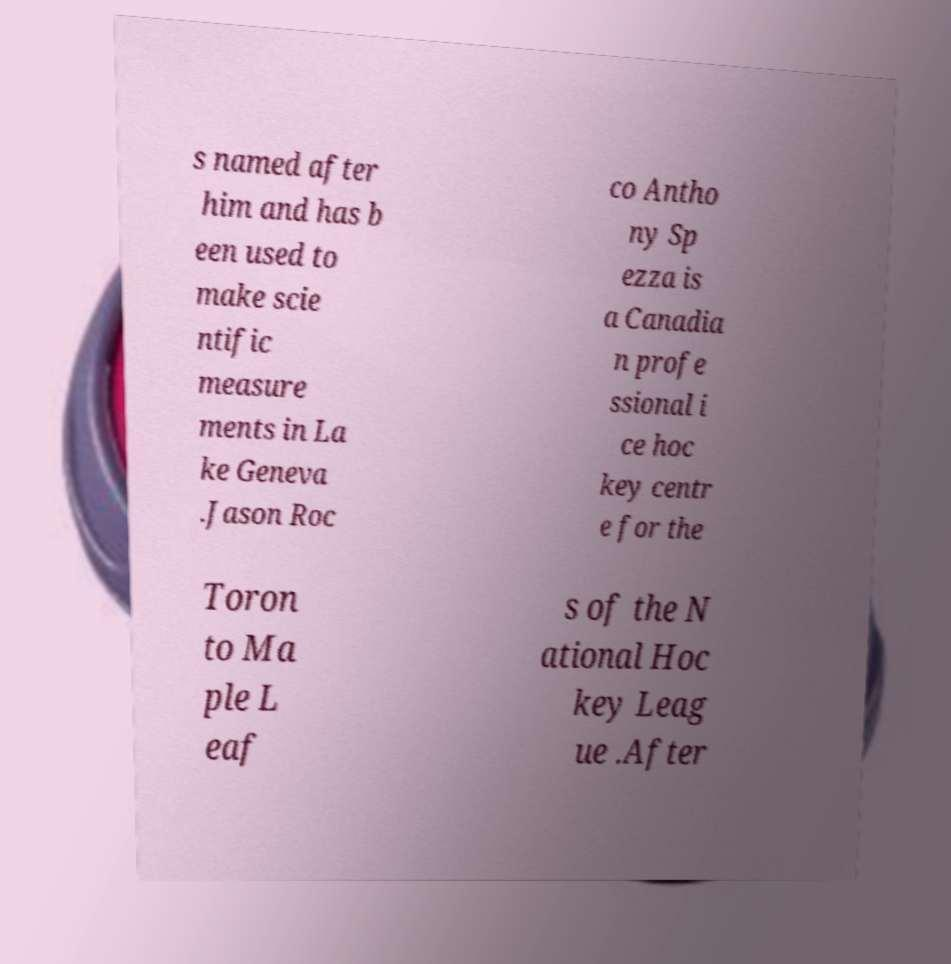I need the written content from this picture converted into text. Can you do that? s named after him and has b een used to make scie ntific measure ments in La ke Geneva .Jason Roc co Antho ny Sp ezza is a Canadia n profe ssional i ce hoc key centr e for the Toron to Ma ple L eaf s of the N ational Hoc key Leag ue .After 